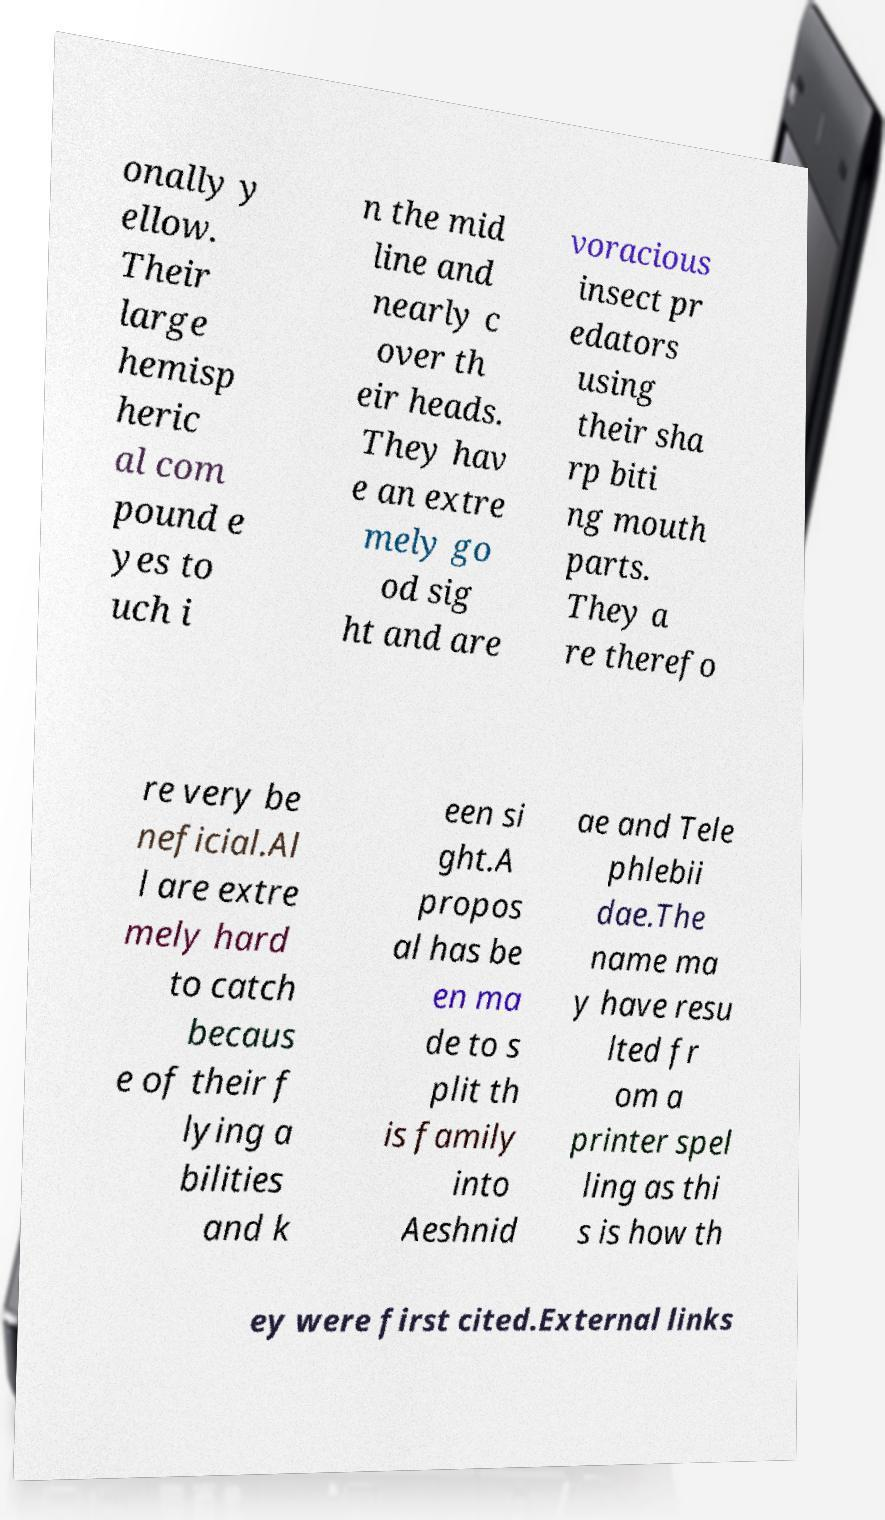What messages or text are displayed in this image? I need them in a readable, typed format. onally y ellow. Their large hemisp heric al com pound e yes to uch i n the mid line and nearly c over th eir heads. They hav e an extre mely go od sig ht and are voracious insect pr edators using their sha rp biti ng mouth parts. They a re therefo re very be neficial.Al l are extre mely hard to catch becaus e of their f lying a bilities and k een si ght.A propos al has be en ma de to s plit th is family into Aeshnid ae and Tele phlebii dae.The name ma y have resu lted fr om a printer spel ling as thi s is how th ey were first cited.External links 